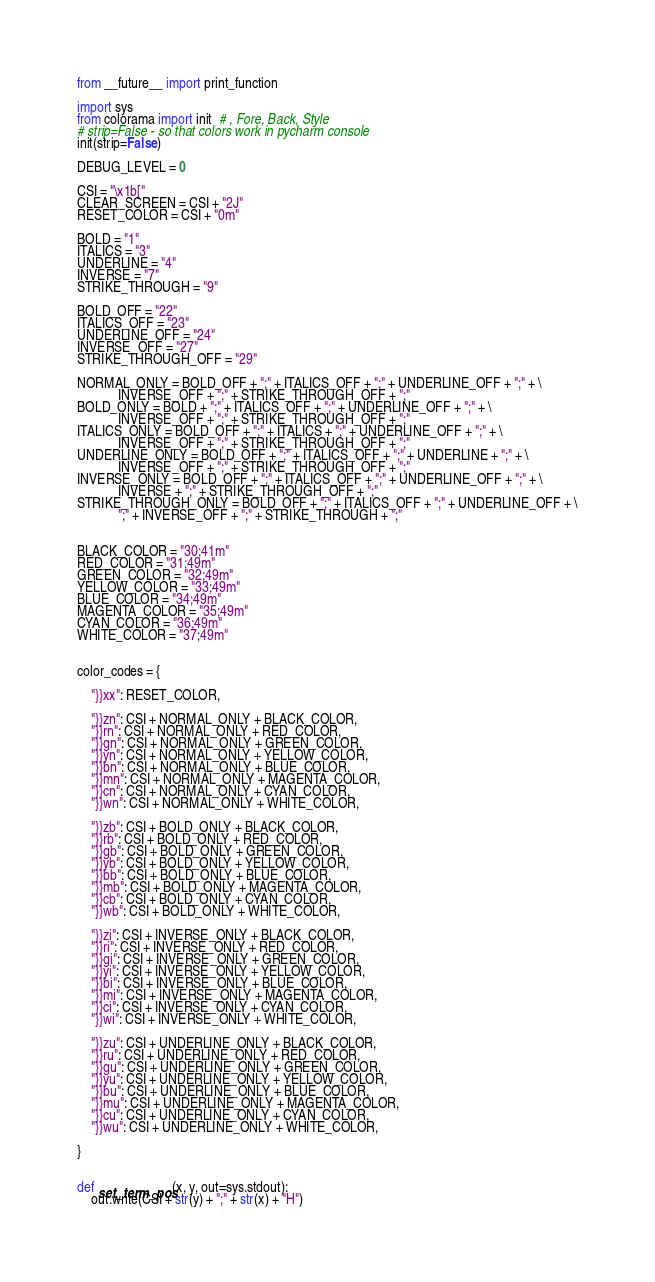Convert code to text. <code><loc_0><loc_0><loc_500><loc_500><_Python_>from __future__ import print_function

import sys
from colorama import init  # , Fore, Back, Style
# strip=False - so that colors work in pycharm console
init(strip=False)

DEBUG_LEVEL = 0

CSI = "\x1b["
CLEAR_SCREEN = CSI + "2J"
RESET_COLOR = CSI + "0m"

BOLD = "1"
ITALICS = "3"
UNDERLINE = "4"
INVERSE = "7"
STRIKE_THROUGH = "9"

BOLD_OFF = "22"
ITALICS_OFF = "23"
UNDERLINE_OFF = "24"
INVERSE_OFF = "27"
STRIKE_THROUGH_OFF = "29"

NORMAL_ONLY = BOLD_OFF + ";" + ITALICS_OFF + ";" + UNDERLINE_OFF + ";" + \
            INVERSE_OFF + ";" + STRIKE_THROUGH_OFF + ";"
BOLD_ONLY = BOLD + ";" + ITALICS_OFF + ";" + UNDERLINE_OFF + ";" + \
            INVERSE_OFF + ";" + STRIKE_THROUGH_OFF + ";"
ITALICS_ONLY = BOLD_OFF + ";" + ITALICS + ";" + UNDERLINE_OFF + ";" + \
            INVERSE_OFF + ";" + STRIKE_THROUGH_OFF + ";"
UNDERLINE_ONLY = BOLD_OFF + ";" + ITALICS_OFF + ";" + UNDERLINE + ";" + \
            INVERSE_OFF + ";" + STRIKE_THROUGH_OFF + ";"
INVERSE_ONLY = BOLD_OFF + ";" + ITALICS_OFF + ";" + UNDERLINE_OFF + ";" + \
            INVERSE + ";" + STRIKE_THROUGH_OFF + ";"
STRIKE_THROUGH_ONLY = BOLD_OFF + ";" + ITALICS_OFF + ";" + UNDERLINE_OFF + \
            ";" + INVERSE_OFF + ";" + STRIKE_THROUGH + ";"


BLACK_COLOR = "30;41m"
RED_COLOR = "31;49m"
GREEN_COLOR = "32;49m"
YELLOW_COLOR = "33;49m"
BLUE_COLOR = "34;49m"
MAGENTA_COLOR = "35;49m"
CYAN_COLOR = "36;49m"
WHITE_COLOR = "37;49m"


color_codes = {

    "}}xx": RESET_COLOR,

    "}}zn": CSI + NORMAL_ONLY + BLACK_COLOR,
    "}}rn": CSI + NORMAL_ONLY + RED_COLOR,
    "}}gn": CSI + NORMAL_ONLY + GREEN_COLOR,
    "}}yn": CSI + NORMAL_ONLY + YELLOW_COLOR,
    "}}bn": CSI + NORMAL_ONLY + BLUE_COLOR,
    "}}mn": CSI + NORMAL_ONLY + MAGENTA_COLOR,
    "}}cn": CSI + NORMAL_ONLY + CYAN_COLOR,
    "}}wn": CSI + NORMAL_ONLY + WHITE_COLOR,

    "}}zb": CSI + BOLD_ONLY + BLACK_COLOR,
    "}}rb": CSI + BOLD_ONLY + RED_COLOR,
    "}}gb": CSI + BOLD_ONLY + GREEN_COLOR,
    "}}yb": CSI + BOLD_ONLY + YELLOW_COLOR,
    "}}bb": CSI + BOLD_ONLY + BLUE_COLOR,
    "}}mb": CSI + BOLD_ONLY + MAGENTA_COLOR,
    "}}cb": CSI + BOLD_ONLY + CYAN_COLOR,
    "}}wb": CSI + BOLD_ONLY + WHITE_COLOR,

    "}}zi": CSI + INVERSE_ONLY + BLACK_COLOR,
    "}}ri": CSI + INVERSE_ONLY + RED_COLOR,
    "}}gi": CSI + INVERSE_ONLY + GREEN_COLOR,
    "}}yi": CSI + INVERSE_ONLY + YELLOW_COLOR,
    "}}bi": CSI + INVERSE_ONLY + BLUE_COLOR,
    "}}mi": CSI + INVERSE_ONLY + MAGENTA_COLOR,
    "}}ci": CSI + INVERSE_ONLY + CYAN_COLOR,
    "}}wi": CSI + INVERSE_ONLY + WHITE_COLOR,

    "}}zu": CSI + UNDERLINE_ONLY + BLACK_COLOR,
    "}}ru": CSI + UNDERLINE_ONLY + RED_COLOR,
    "}}gu": CSI + UNDERLINE_ONLY + GREEN_COLOR,
    "}}yu": CSI + UNDERLINE_ONLY + YELLOW_COLOR,
    "}}bu": CSI + UNDERLINE_ONLY + BLUE_COLOR,
    "}}mu": CSI + UNDERLINE_ONLY + MAGENTA_COLOR,
    "}}cu": CSI + UNDERLINE_ONLY + CYAN_COLOR,
    "}}wu": CSI + UNDERLINE_ONLY + WHITE_COLOR,

}


def set_term_pos(x, y, out=sys.stdout):
    out.write(CSI + str(y) + ";" + str(x) + "H")

</code> 